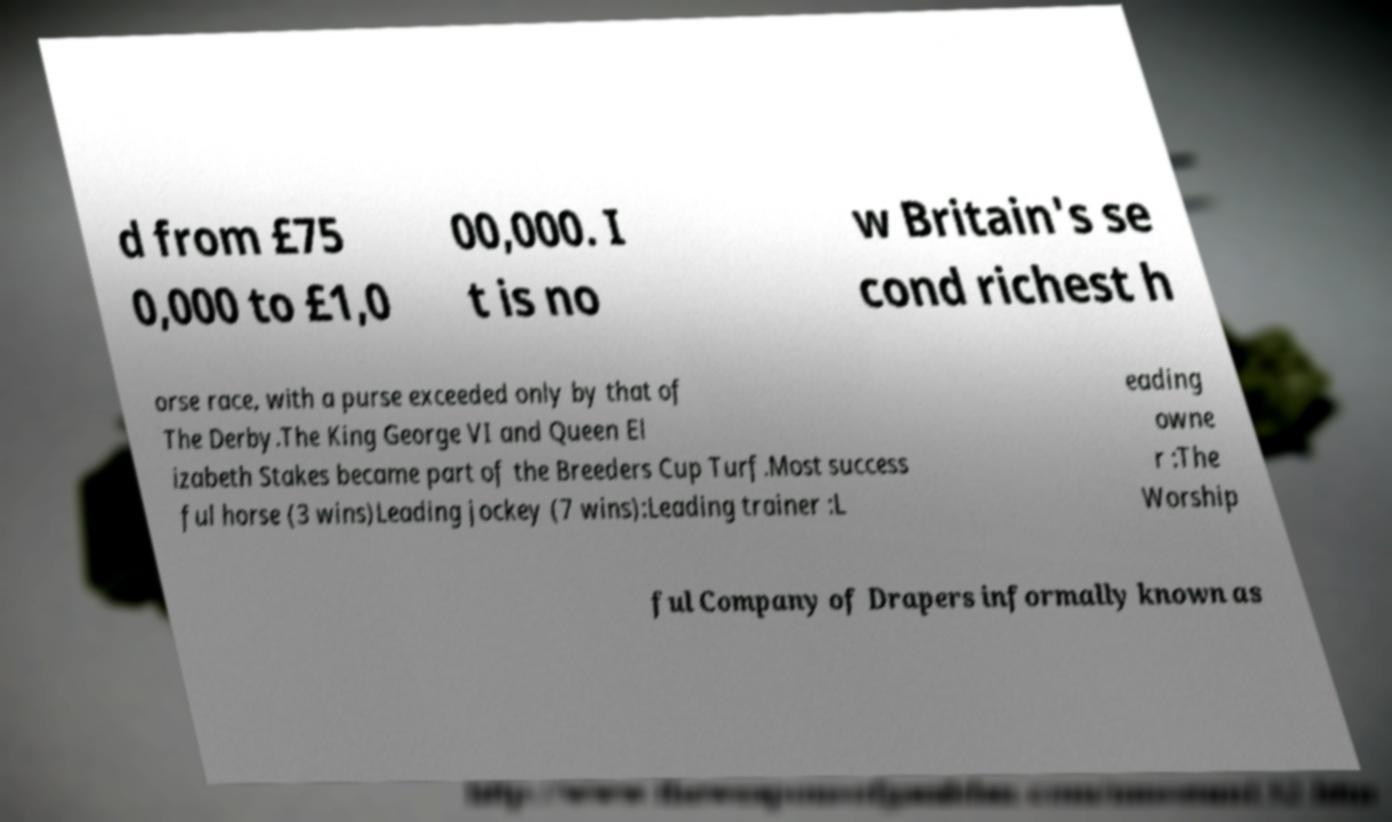What messages or text are displayed in this image? I need them in a readable, typed format. d from £75 0,000 to £1,0 00,000. I t is no w Britain's se cond richest h orse race, with a purse exceeded only by that of The Derby.The King George VI and Queen El izabeth Stakes became part of the Breeders Cup Turf.Most success ful horse (3 wins)Leading jockey (7 wins):Leading trainer :L eading owne r :The Worship ful Company of Drapers informally known as 